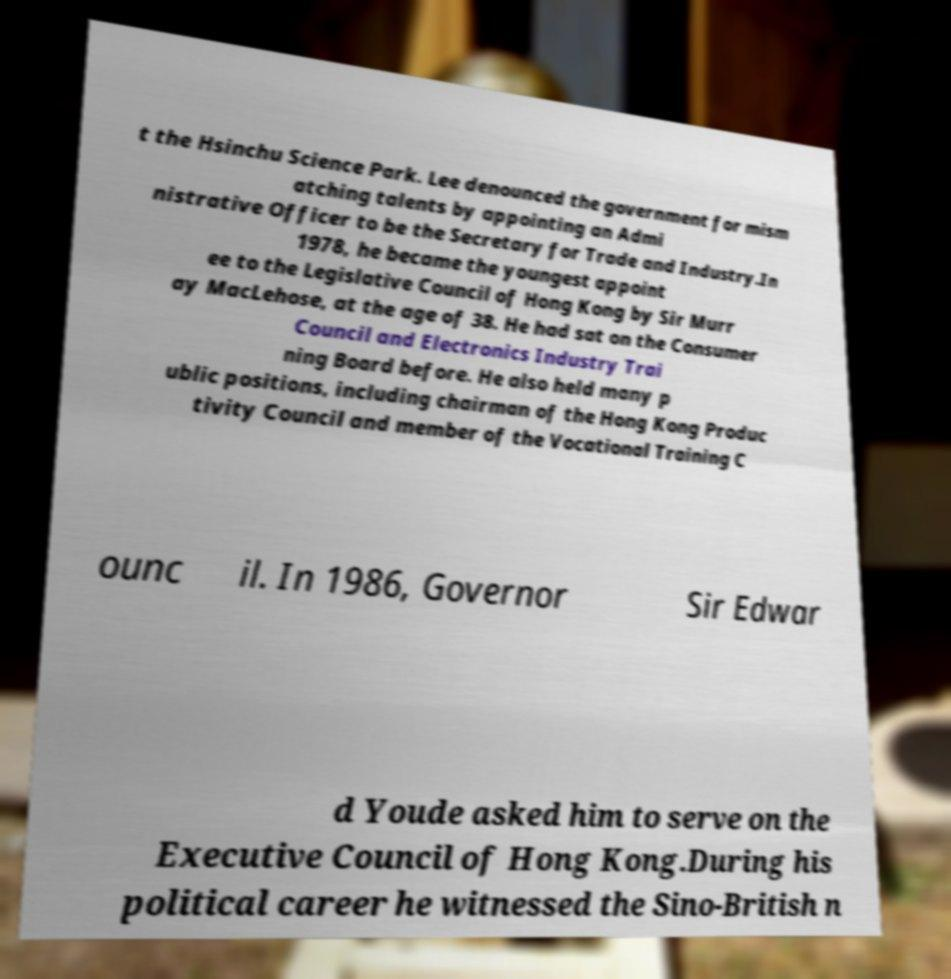Could you assist in decoding the text presented in this image and type it out clearly? t the Hsinchu Science Park. Lee denounced the government for mism atching talents by appointing an Admi nistrative Officer to be the Secretary for Trade and Industry.In 1978, he became the youngest appoint ee to the Legislative Council of Hong Kong by Sir Murr ay MacLehose, at the age of 38. He had sat on the Consumer Council and Electronics Industry Trai ning Board before. He also held many p ublic positions, including chairman of the Hong Kong Produc tivity Council and member of the Vocational Training C ounc il. In 1986, Governor Sir Edwar d Youde asked him to serve on the Executive Council of Hong Kong.During his political career he witnessed the Sino-British n 